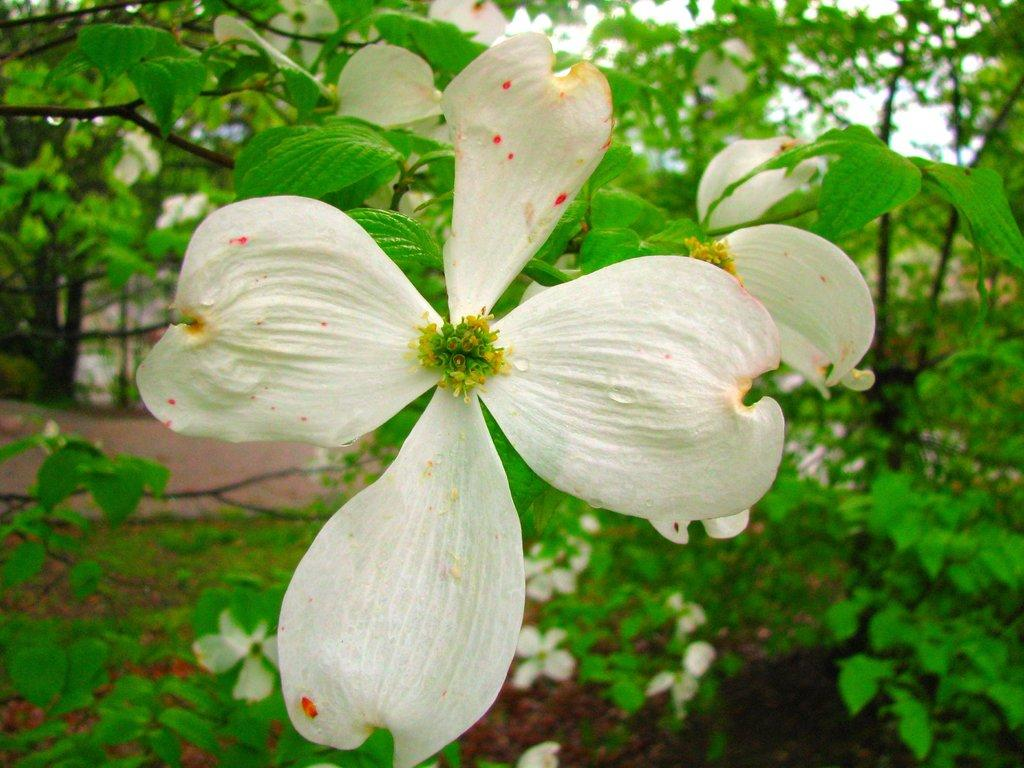What is the main subject of the picture? The main subject of the picture is a tree. What can be observed about the tree's appearance? The tree has white flowers on it. What else is visible in the picture besides the tree? There are leaves beside and behind the tree. How does the tree express regret in the image? Trees do not have the ability to express regret, as they are inanimate objects. 